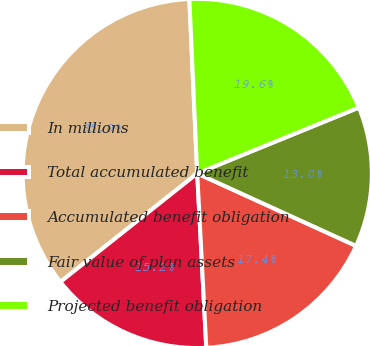Convert chart to OTSL. <chart><loc_0><loc_0><loc_500><loc_500><pie_chart><fcel>In millions<fcel>Total accumulated benefit<fcel>Accumulated benefit obligation<fcel>Fair value of plan assets<fcel>Projected benefit obligation<nl><fcel>34.95%<fcel>15.16%<fcel>17.36%<fcel>12.97%<fcel>19.56%<nl></chart> 